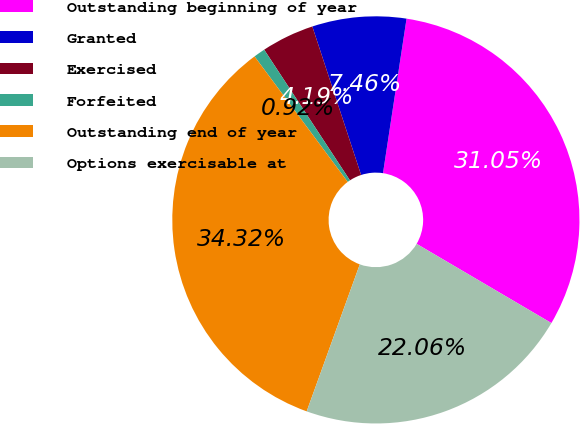Convert chart to OTSL. <chart><loc_0><loc_0><loc_500><loc_500><pie_chart><fcel>Outstanding beginning of year<fcel>Granted<fcel>Exercised<fcel>Forfeited<fcel>Outstanding end of year<fcel>Options exercisable at<nl><fcel>31.05%<fcel>7.46%<fcel>4.19%<fcel>0.92%<fcel>34.32%<fcel>22.06%<nl></chart> 